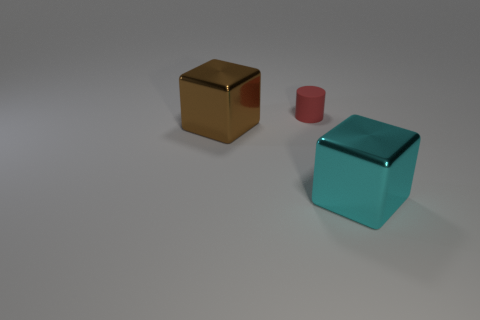Are there any other things that have the same size as the cyan metal object?
Keep it short and to the point. Yes. Is the size of the block to the right of the brown shiny cube the same as the red rubber cylinder?
Ensure brevity in your answer.  No. There is a large metal thing behind the shiny block that is in front of the big thing that is left of the large cyan cube; what shape is it?
Ensure brevity in your answer.  Cube. How many objects are either small yellow rubber things or brown cubes in front of the red cylinder?
Provide a succinct answer. 1. What size is the block that is right of the brown cube?
Keep it short and to the point. Large. Are the brown cube and the large cube that is in front of the brown thing made of the same material?
Your answer should be very brief. Yes. How many metal objects are in front of the metal thing left of the object that is right of the small red object?
Your answer should be very brief. 1. What number of red things are either metallic things or things?
Offer a very short reply. 1. There is a big shiny object on the right side of the big brown cube; what is its shape?
Offer a terse response. Cube. There is a object that is the same size as the cyan shiny cube; what color is it?
Offer a very short reply. Brown. 